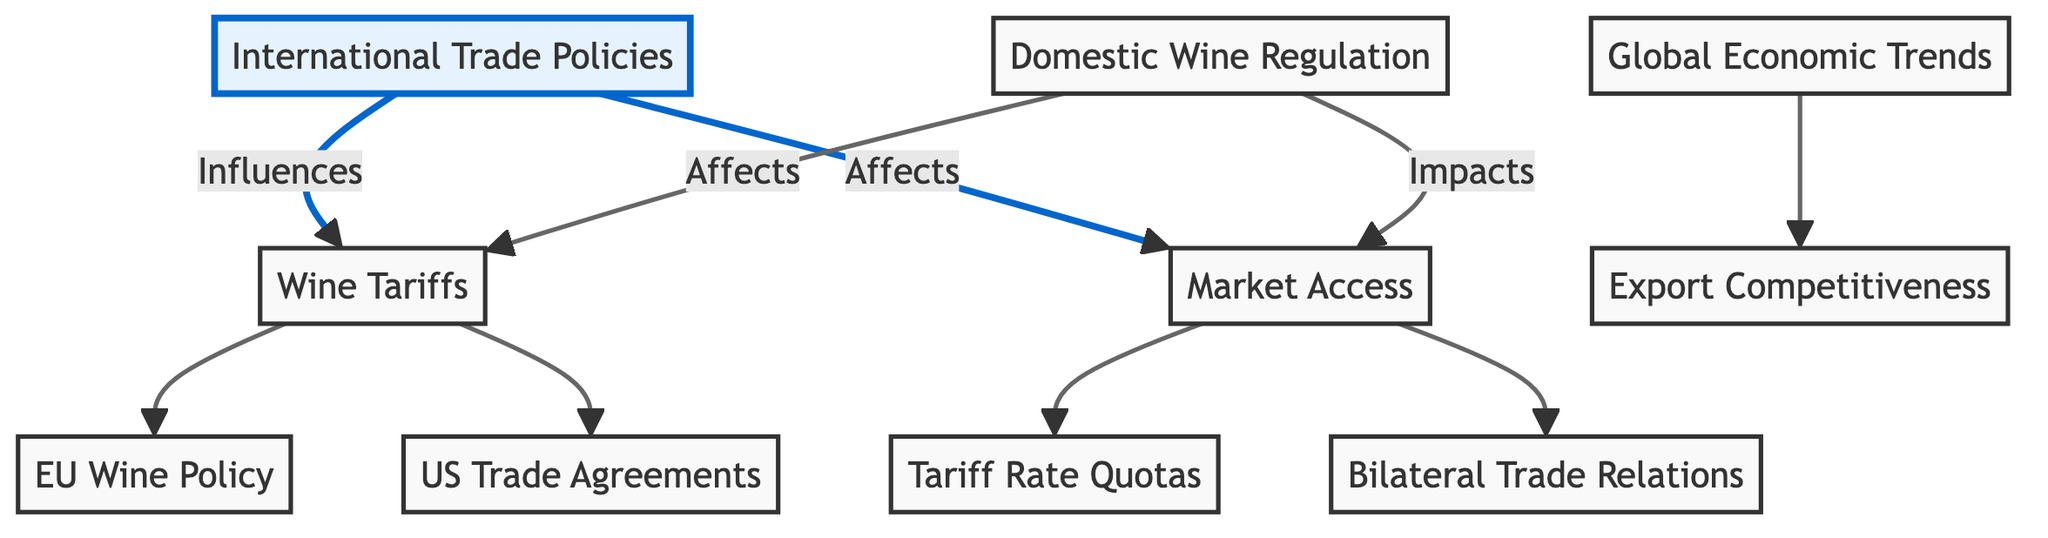What influences wine tariffs? The diagram shows an arrow from "International Trade Policies" to "Wine Tariffs," indicating that international trade policies influence wine tariffs.
Answer: International Trade Policies How many nodes are in the diagram? By counting the listed nodes, there are a total of ten distinct nodes presented in the diagram.
Answer: 10 What is the direct impact of domestic wine regulation on market access? The diagram displays an arrow from "Domestic Wine Regulation" to "Market Access," which signifies that it directly impacts market access.
Answer: Impacts Which node has the most incoming edges? Upon reviewing the diagram, "Market Access" has three incoming edges (from "International Trade Policies," "Domestic Wine Regulation," and "Tariff Rate Quotas").
Answer: Market Access What do EU wine policy and US trade agreements have in common? Both nodes are connected by outgoing edges from "Wine Tariffs," establishing that they are influenced by wine tariffs.
Answer: Influenced by wine tariffs What is the influence of global economic trends on the wine market? The arrow from "Global Economic Trends" to "Export Competitiveness" indicates that global economic trends influence export competitiveness in the wine market.
Answer: Influences export competitiveness What is the relationship between market access and tariff rate quotas? The diagram clearly displays a direct arrow from "Market Access" to "Tariff Rate Quotas," demonstrating that market access directly affects tariff rate quotas.
Answer: Affects How are bilateral trade relations connected to market access? There is a direct link indicating that "Market Access" is influenced by "Bilateral Trade Relations" in the diagram.
Answer: Influenced by What type of connection exists between wine tariffs and domestic wine regulation? The diagram shows that domestic wine regulation impacts wine tariffs, represented by a directed arrow from "Domestic Wine Regulation" to "Wine Tariffs."
Answer: Impacts 